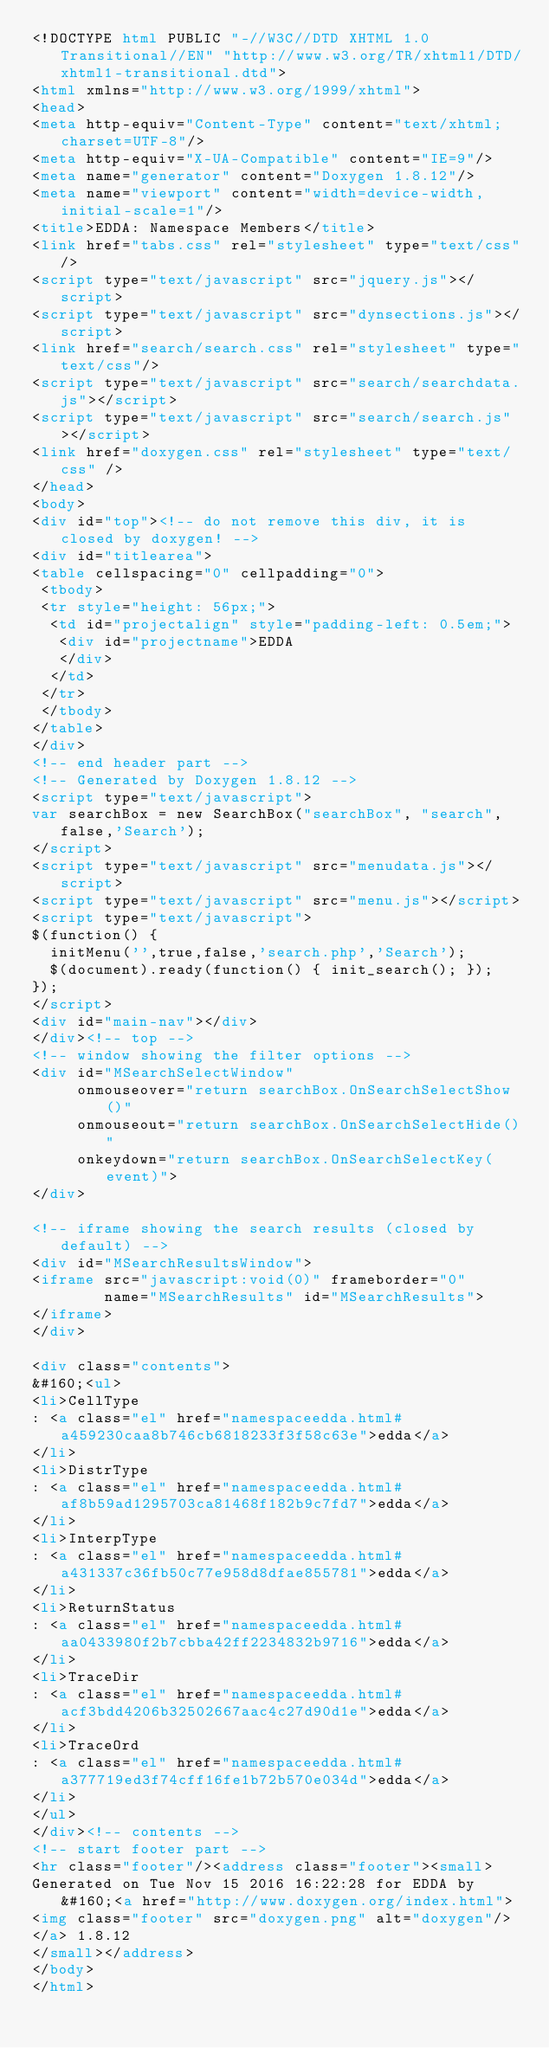<code> <loc_0><loc_0><loc_500><loc_500><_HTML_><!DOCTYPE html PUBLIC "-//W3C//DTD XHTML 1.0 Transitional//EN" "http://www.w3.org/TR/xhtml1/DTD/xhtml1-transitional.dtd">
<html xmlns="http://www.w3.org/1999/xhtml">
<head>
<meta http-equiv="Content-Type" content="text/xhtml;charset=UTF-8"/>
<meta http-equiv="X-UA-Compatible" content="IE=9"/>
<meta name="generator" content="Doxygen 1.8.12"/>
<meta name="viewport" content="width=device-width, initial-scale=1"/>
<title>EDDA: Namespace Members</title>
<link href="tabs.css" rel="stylesheet" type="text/css"/>
<script type="text/javascript" src="jquery.js"></script>
<script type="text/javascript" src="dynsections.js"></script>
<link href="search/search.css" rel="stylesheet" type="text/css"/>
<script type="text/javascript" src="search/searchdata.js"></script>
<script type="text/javascript" src="search/search.js"></script>
<link href="doxygen.css" rel="stylesheet" type="text/css" />
</head>
<body>
<div id="top"><!-- do not remove this div, it is closed by doxygen! -->
<div id="titlearea">
<table cellspacing="0" cellpadding="0">
 <tbody>
 <tr style="height: 56px;">
  <td id="projectalign" style="padding-left: 0.5em;">
   <div id="projectname">EDDA
   </div>
  </td>
 </tr>
 </tbody>
</table>
</div>
<!-- end header part -->
<!-- Generated by Doxygen 1.8.12 -->
<script type="text/javascript">
var searchBox = new SearchBox("searchBox", "search",false,'Search');
</script>
<script type="text/javascript" src="menudata.js"></script>
<script type="text/javascript" src="menu.js"></script>
<script type="text/javascript">
$(function() {
  initMenu('',true,false,'search.php','Search');
  $(document).ready(function() { init_search(); });
});
</script>
<div id="main-nav"></div>
</div><!-- top -->
<!-- window showing the filter options -->
<div id="MSearchSelectWindow"
     onmouseover="return searchBox.OnSearchSelectShow()"
     onmouseout="return searchBox.OnSearchSelectHide()"
     onkeydown="return searchBox.OnSearchSelectKey(event)">
</div>

<!-- iframe showing the search results (closed by default) -->
<div id="MSearchResultsWindow">
<iframe src="javascript:void(0)" frameborder="0" 
        name="MSearchResults" id="MSearchResults">
</iframe>
</div>

<div class="contents">
&#160;<ul>
<li>CellType
: <a class="el" href="namespaceedda.html#a459230caa8b746cb6818233f3f58c63e">edda</a>
</li>
<li>DistrType
: <a class="el" href="namespaceedda.html#af8b59ad1295703ca81468f182b9c7fd7">edda</a>
</li>
<li>InterpType
: <a class="el" href="namespaceedda.html#a431337c36fb50c77e958d8dfae855781">edda</a>
</li>
<li>ReturnStatus
: <a class="el" href="namespaceedda.html#aa0433980f2b7cbba42ff2234832b9716">edda</a>
</li>
<li>TraceDir
: <a class="el" href="namespaceedda.html#acf3bdd4206b32502667aac4c27d90d1e">edda</a>
</li>
<li>TraceOrd
: <a class="el" href="namespaceedda.html#a377719ed3f74cff16fe1b72b570e034d">edda</a>
</li>
</ul>
</div><!-- contents -->
<!-- start footer part -->
<hr class="footer"/><address class="footer"><small>
Generated on Tue Nov 15 2016 16:22:28 for EDDA by &#160;<a href="http://www.doxygen.org/index.html">
<img class="footer" src="doxygen.png" alt="doxygen"/>
</a> 1.8.12
</small></address>
</body>
</html>
</code> 